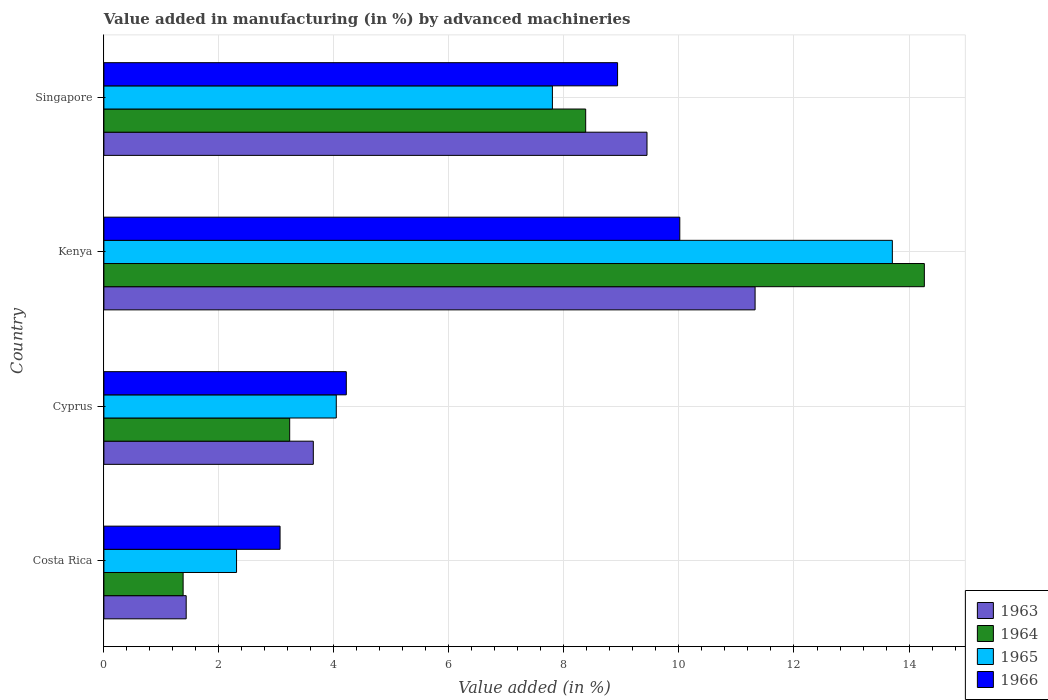How many different coloured bars are there?
Your answer should be very brief. 4. How many bars are there on the 1st tick from the top?
Your response must be concise. 4. How many bars are there on the 1st tick from the bottom?
Your answer should be very brief. 4. What is the label of the 3rd group of bars from the top?
Your response must be concise. Cyprus. What is the percentage of value added in manufacturing by advanced machineries in 1966 in Kenya?
Keep it short and to the point. 10.01. Across all countries, what is the maximum percentage of value added in manufacturing by advanced machineries in 1966?
Offer a very short reply. 10.01. Across all countries, what is the minimum percentage of value added in manufacturing by advanced machineries in 1965?
Ensure brevity in your answer.  2.31. In which country was the percentage of value added in manufacturing by advanced machineries in 1965 maximum?
Provide a short and direct response. Kenya. In which country was the percentage of value added in manufacturing by advanced machineries in 1963 minimum?
Provide a succinct answer. Costa Rica. What is the total percentage of value added in manufacturing by advanced machineries in 1966 in the graph?
Your response must be concise. 26.23. What is the difference between the percentage of value added in manufacturing by advanced machineries in 1963 in Costa Rica and that in Kenya?
Make the answer very short. -9.89. What is the difference between the percentage of value added in manufacturing by advanced machineries in 1964 in Costa Rica and the percentage of value added in manufacturing by advanced machineries in 1965 in Singapore?
Give a very brief answer. -6.42. What is the average percentage of value added in manufacturing by advanced machineries in 1964 per country?
Your answer should be compact. 6.81. What is the difference between the percentage of value added in manufacturing by advanced machineries in 1964 and percentage of value added in manufacturing by advanced machineries in 1965 in Singapore?
Your answer should be compact. 0.58. What is the ratio of the percentage of value added in manufacturing by advanced machineries in 1963 in Kenya to that in Singapore?
Your answer should be very brief. 1.2. Is the difference between the percentage of value added in manufacturing by advanced machineries in 1964 in Cyprus and Singapore greater than the difference between the percentage of value added in manufacturing by advanced machineries in 1965 in Cyprus and Singapore?
Make the answer very short. No. What is the difference between the highest and the second highest percentage of value added in manufacturing by advanced machineries in 1966?
Your response must be concise. 1.08. What is the difference between the highest and the lowest percentage of value added in manufacturing by advanced machineries in 1963?
Make the answer very short. 9.89. In how many countries, is the percentage of value added in manufacturing by advanced machineries in 1966 greater than the average percentage of value added in manufacturing by advanced machineries in 1966 taken over all countries?
Give a very brief answer. 2. What does the 4th bar from the bottom in Cyprus represents?
Your answer should be compact. 1966. How many bars are there?
Make the answer very short. 16. Are all the bars in the graph horizontal?
Provide a short and direct response. Yes. What is the difference between two consecutive major ticks on the X-axis?
Provide a short and direct response. 2. Does the graph contain any zero values?
Provide a short and direct response. No. Does the graph contain grids?
Your response must be concise. Yes. How many legend labels are there?
Give a very brief answer. 4. How are the legend labels stacked?
Make the answer very short. Vertical. What is the title of the graph?
Provide a short and direct response. Value added in manufacturing (in %) by advanced machineries. Does "1991" appear as one of the legend labels in the graph?
Keep it short and to the point. No. What is the label or title of the X-axis?
Your response must be concise. Value added (in %). What is the label or title of the Y-axis?
Your answer should be very brief. Country. What is the Value added (in %) in 1963 in Costa Rica?
Your response must be concise. 1.43. What is the Value added (in %) of 1964 in Costa Rica?
Your answer should be compact. 1.38. What is the Value added (in %) of 1965 in Costa Rica?
Make the answer very short. 2.31. What is the Value added (in %) in 1966 in Costa Rica?
Make the answer very short. 3.06. What is the Value added (in %) of 1963 in Cyprus?
Offer a terse response. 3.64. What is the Value added (in %) of 1964 in Cyprus?
Provide a succinct answer. 3.23. What is the Value added (in %) of 1965 in Cyprus?
Offer a terse response. 4.04. What is the Value added (in %) in 1966 in Cyprus?
Offer a very short reply. 4.22. What is the Value added (in %) of 1963 in Kenya?
Give a very brief answer. 11.32. What is the Value added (in %) in 1964 in Kenya?
Your response must be concise. 14.27. What is the Value added (in %) of 1965 in Kenya?
Give a very brief answer. 13.71. What is the Value added (in %) in 1966 in Kenya?
Offer a terse response. 10.01. What is the Value added (in %) of 1963 in Singapore?
Your response must be concise. 9.44. What is the Value added (in %) in 1964 in Singapore?
Ensure brevity in your answer.  8.38. What is the Value added (in %) in 1965 in Singapore?
Offer a very short reply. 7.8. What is the Value added (in %) of 1966 in Singapore?
Offer a very short reply. 8.93. Across all countries, what is the maximum Value added (in %) in 1963?
Give a very brief answer. 11.32. Across all countries, what is the maximum Value added (in %) of 1964?
Provide a succinct answer. 14.27. Across all countries, what is the maximum Value added (in %) of 1965?
Offer a very short reply. 13.71. Across all countries, what is the maximum Value added (in %) of 1966?
Your response must be concise. 10.01. Across all countries, what is the minimum Value added (in %) of 1963?
Your answer should be compact. 1.43. Across all countries, what is the minimum Value added (in %) in 1964?
Your answer should be very brief. 1.38. Across all countries, what is the minimum Value added (in %) of 1965?
Keep it short and to the point. 2.31. Across all countries, what is the minimum Value added (in %) in 1966?
Provide a succinct answer. 3.06. What is the total Value added (in %) in 1963 in the graph?
Keep it short and to the point. 25.84. What is the total Value added (in %) in 1964 in the graph?
Make the answer very short. 27.25. What is the total Value added (in %) of 1965 in the graph?
Make the answer very short. 27.86. What is the total Value added (in %) in 1966 in the graph?
Keep it short and to the point. 26.23. What is the difference between the Value added (in %) of 1963 in Costa Rica and that in Cyprus?
Provide a succinct answer. -2.21. What is the difference between the Value added (in %) in 1964 in Costa Rica and that in Cyprus?
Your answer should be compact. -1.85. What is the difference between the Value added (in %) in 1965 in Costa Rica and that in Cyprus?
Offer a very short reply. -1.73. What is the difference between the Value added (in %) in 1966 in Costa Rica and that in Cyprus?
Your response must be concise. -1.15. What is the difference between the Value added (in %) in 1963 in Costa Rica and that in Kenya?
Offer a terse response. -9.89. What is the difference between the Value added (in %) of 1964 in Costa Rica and that in Kenya?
Your answer should be compact. -12.89. What is the difference between the Value added (in %) of 1965 in Costa Rica and that in Kenya?
Your answer should be compact. -11.4. What is the difference between the Value added (in %) of 1966 in Costa Rica and that in Kenya?
Keep it short and to the point. -6.95. What is the difference between the Value added (in %) of 1963 in Costa Rica and that in Singapore?
Offer a terse response. -8.01. What is the difference between the Value added (in %) in 1964 in Costa Rica and that in Singapore?
Offer a very short reply. -7. What is the difference between the Value added (in %) of 1965 in Costa Rica and that in Singapore?
Provide a succinct answer. -5.49. What is the difference between the Value added (in %) of 1966 in Costa Rica and that in Singapore?
Make the answer very short. -5.87. What is the difference between the Value added (in %) of 1963 in Cyprus and that in Kenya?
Offer a very short reply. -7.68. What is the difference between the Value added (in %) of 1964 in Cyprus and that in Kenya?
Your response must be concise. -11.04. What is the difference between the Value added (in %) in 1965 in Cyprus and that in Kenya?
Your answer should be compact. -9.67. What is the difference between the Value added (in %) in 1966 in Cyprus and that in Kenya?
Your response must be concise. -5.8. What is the difference between the Value added (in %) of 1963 in Cyprus and that in Singapore?
Your answer should be very brief. -5.8. What is the difference between the Value added (in %) in 1964 in Cyprus and that in Singapore?
Keep it short and to the point. -5.15. What is the difference between the Value added (in %) of 1965 in Cyprus and that in Singapore?
Offer a very short reply. -3.76. What is the difference between the Value added (in %) of 1966 in Cyprus and that in Singapore?
Offer a terse response. -4.72. What is the difference between the Value added (in %) of 1963 in Kenya and that in Singapore?
Offer a terse response. 1.88. What is the difference between the Value added (in %) in 1964 in Kenya and that in Singapore?
Provide a short and direct response. 5.89. What is the difference between the Value added (in %) in 1965 in Kenya and that in Singapore?
Ensure brevity in your answer.  5.91. What is the difference between the Value added (in %) of 1966 in Kenya and that in Singapore?
Keep it short and to the point. 1.08. What is the difference between the Value added (in %) in 1963 in Costa Rica and the Value added (in %) in 1964 in Cyprus?
Ensure brevity in your answer.  -1.8. What is the difference between the Value added (in %) of 1963 in Costa Rica and the Value added (in %) of 1965 in Cyprus?
Your response must be concise. -2.61. What is the difference between the Value added (in %) of 1963 in Costa Rica and the Value added (in %) of 1966 in Cyprus?
Your response must be concise. -2.78. What is the difference between the Value added (in %) in 1964 in Costa Rica and the Value added (in %) in 1965 in Cyprus?
Your response must be concise. -2.66. What is the difference between the Value added (in %) in 1964 in Costa Rica and the Value added (in %) in 1966 in Cyprus?
Offer a terse response. -2.84. What is the difference between the Value added (in %) of 1965 in Costa Rica and the Value added (in %) of 1966 in Cyprus?
Provide a succinct answer. -1.91. What is the difference between the Value added (in %) in 1963 in Costa Rica and the Value added (in %) in 1964 in Kenya?
Offer a very short reply. -12.84. What is the difference between the Value added (in %) in 1963 in Costa Rica and the Value added (in %) in 1965 in Kenya?
Offer a terse response. -12.28. What is the difference between the Value added (in %) in 1963 in Costa Rica and the Value added (in %) in 1966 in Kenya?
Make the answer very short. -8.58. What is the difference between the Value added (in %) in 1964 in Costa Rica and the Value added (in %) in 1965 in Kenya?
Keep it short and to the point. -12.33. What is the difference between the Value added (in %) in 1964 in Costa Rica and the Value added (in %) in 1966 in Kenya?
Make the answer very short. -8.64. What is the difference between the Value added (in %) in 1965 in Costa Rica and the Value added (in %) in 1966 in Kenya?
Keep it short and to the point. -7.71. What is the difference between the Value added (in %) in 1963 in Costa Rica and the Value added (in %) in 1964 in Singapore?
Your answer should be very brief. -6.95. What is the difference between the Value added (in %) of 1963 in Costa Rica and the Value added (in %) of 1965 in Singapore?
Provide a short and direct response. -6.37. What is the difference between the Value added (in %) of 1963 in Costa Rica and the Value added (in %) of 1966 in Singapore?
Provide a short and direct response. -7.5. What is the difference between the Value added (in %) in 1964 in Costa Rica and the Value added (in %) in 1965 in Singapore?
Ensure brevity in your answer.  -6.42. What is the difference between the Value added (in %) of 1964 in Costa Rica and the Value added (in %) of 1966 in Singapore?
Provide a succinct answer. -7.55. What is the difference between the Value added (in %) in 1965 in Costa Rica and the Value added (in %) in 1966 in Singapore?
Offer a terse response. -6.63. What is the difference between the Value added (in %) of 1963 in Cyprus and the Value added (in %) of 1964 in Kenya?
Keep it short and to the point. -10.63. What is the difference between the Value added (in %) of 1963 in Cyprus and the Value added (in %) of 1965 in Kenya?
Offer a very short reply. -10.07. What is the difference between the Value added (in %) in 1963 in Cyprus and the Value added (in %) in 1966 in Kenya?
Ensure brevity in your answer.  -6.37. What is the difference between the Value added (in %) in 1964 in Cyprus and the Value added (in %) in 1965 in Kenya?
Your answer should be compact. -10.48. What is the difference between the Value added (in %) of 1964 in Cyprus and the Value added (in %) of 1966 in Kenya?
Provide a succinct answer. -6.78. What is the difference between the Value added (in %) of 1965 in Cyprus and the Value added (in %) of 1966 in Kenya?
Give a very brief answer. -5.97. What is the difference between the Value added (in %) in 1963 in Cyprus and the Value added (in %) in 1964 in Singapore?
Keep it short and to the point. -4.74. What is the difference between the Value added (in %) of 1963 in Cyprus and the Value added (in %) of 1965 in Singapore?
Ensure brevity in your answer.  -4.16. What is the difference between the Value added (in %) of 1963 in Cyprus and the Value added (in %) of 1966 in Singapore?
Ensure brevity in your answer.  -5.29. What is the difference between the Value added (in %) in 1964 in Cyprus and the Value added (in %) in 1965 in Singapore?
Keep it short and to the point. -4.57. What is the difference between the Value added (in %) in 1964 in Cyprus and the Value added (in %) in 1966 in Singapore?
Your response must be concise. -5.7. What is the difference between the Value added (in %) in 1965 in Cyprus and the Value added (in %) in 1966 in Singapore?
Keep it short and to the point. -4.89. What is the difference between the Value added (in %) in 1963 in Kenya and the Value added (in %) in 1964 in Singapore?
Offer a terse response. 2.95. What is the difference between the Value added (in %) of 1963 in Kenya and the Value added (in %) of 1965 in Singapore?
Make the answer very short. 3.52. What is the difference between the Value added (in %) in 1963 in Kenya and the Value added (in %) in 1966 in Singapore?
Offer a very short reply. 2.39. What is the difference between the Value added (in %) in 1964 in Kenya and the Value added (in %) in 1965 in Singapore?
Provide a short and direct response. 6.47. What is the difference between the Value added (in %) of 1964 in Kenya and the Value added (in %) of 1966 in Singapore?
Your response must be concise. 5.33. What is the difference between the Value added (in %) of 1965 in Kenya and the Value added (in %) of 1966 in Singapore?
Provide a short and direct response. 4.78. What is the average Value added (in %) in 1963 per country?
Keep it short and to the point. 6.46. What is the average Value added (in %) of 1964 per country?
Your answer should be very brief. 6.81. What is the average Value added (in %) of 1965 per country?
Keep it short and to the point. 6.96. What is the average Value added (in %) of 1966 per country?
Your answer should be compact. 6.56. What is the difference between the Value added (in %) in 1963 and Value added (in %) in 1964 in Costa Rica?
Your answer should be compact. 0.05. What is the difference between the Value added (in %) of 1963 and Value added (in %) of 1965 in Costa Rica?
Offer a very short reply. -0.88. What is the difference between the Value added (in %) in 1963 and Value added (in %) in 1966 in Costa Rica?
Offer a very short reply. -1.63. What is the difference between the Value added (in %) of 1964 and Value added (in %) of 1965 in Costa Rica?
Your response must be concise. -0.93. What is the difference between the Value added (in %) of 1964 and Value added (in %) of 1966 in Costa Rica?
Your response must be concise. -1.69. What is the difference between the Value added (in %) of 1965 and Value added (in %) of 1966 in Costa Rica?
Make the answer very short. -0.76. What is the difference between the Value added (in %) of 1963 and Value added (in %) of 1964 in Cyprus?
Your response must be concise. 0.41. What is the difference between the Value added (in %) in 1963 and Value added (in %) in 1965 in Cyprus?
Offer a terse response. -0.4. What is the difference between the Value added (in %) in 1963 and Value added (in %) in 1966 in Cyprus?
Keep it short and to the point. -0.57. What is the difference between the Value added (in %) in 1964 and Value added (in %) in 1965 in Cyprus?
Offer a terse response. -0.81. What is the difference between the Value added (in %) in 1964 and Value added (in %) in 1966 in Cyprus?
Your response must be concise. -0.98. What is the difference between the Value added (in %) of 1965 and Value added (in %) of 1966 in Cyprus?
Offer a very short reply. -0.17. What is the difference between the Value added (in %) in 1963 and Value added (in %) in 1964 in Kenya?
Provide a succinct answer. -2.94. What is the difference between the Value added (in %) in 1963 and Value added (in %) in 1965 in Kenya?
Provide a succinct answer. -2.39. What is the difference between the Value added (in %) in 1963 and Value added (in %) in 1966 in Kenya?
Offer a very short reply. 1.31. What is the difference between the Value added (in %) in 1964 and Value added (in %) in 1965 in Kenya?
Make the answer very short. 0.56. What is the difference between the Value added (in %) of 1964 and Value added (in %) of 1966 in Kenya?
Keep it short and to the point. 4.25. What is the difference between the Value added (in %) in 1965 and Value added (in %) in 1966 in Kenya?
Ensure brevity in your answer.  3.7. What is the difference between the Value added (in %) of 1963 and Value added (in %) of 1964 in Singapore?
Your answer should be very brief. 1.07. What is the difference between the Value added (in %) in 1963 and Value added (in %) in 1965 in Singapore?
Your answer should be very brief. 1.64. What is the difference between the Value added (in %) of 1963 and Value added (in %) of 1966 in Singapore?
Give a very brief answer. 0.51. What is the difference between the Value added (in %) of 1964 and Value added (in %) of 1965 in Singapore?
Ensure brevity in your answer.  0.58. What is the difference between the Value added (in %) of 1964 and Value added (in %) of 1966 in Singapore?
Provide a short and direct response. -0.55. What is the difference between the Value added (in %) of 1965 and Value added (in %) of 1966 in Singapore?
Offer a terse response. -1.13. What is the ratio of the Value added (in %) in 1963 in Costa Rica to that in Cyprus?
Keep it short and to the point. 0.39. What is the ratio of the Value added (in %) in 1964 in Costa Rica to that in Cyprus?
Your answer should be compact. 0.43. What is the ratio of the Value added (in %) of 1965 in Costa Rica to that in Cyprus?
Provide a short and direct response. 0.57. What is the ratio of the Value added (in %) of 1966 in Costa Rica to that in Cyprus?
Provide a short and direct response. 0.73. What is the ratio of the Value added (in %) in 1963 in Costa Rica to that in Kenya?
Your answer should be very brief. 0.13. What is the ratio of the Value added (in %) in 1964 in Costa Rica to that in Kenya?
Make the answer very short. 0.1. What is the ratio of the Value added (in %) in 1965 in Costa Rica to that in Kenya?
Offer a terse response. 0.17. What is the ratio of the Value added (in %) of 1966 in Costa Rica to that in Kenya?
Offer a terse response. 0.31. What is the ratio of the Value added (in %) in 1963 in Costa Rica to that in Singapore?
Offer a terse response. 0.15. What is the ratio of the Value added (in %) in 1964 in Costa Rica to that in Singapore?
Your response must be concise. 0.16. What is the ratio of the Value added (in %) of 1965 in Costa Rica to that in Singapore?
Offer a very short reply. 0.3. What is the ratio of the Value added (in %) in 1966 in Costa Rica to that in Singapore?
Make the answer very short. 0.34. What is the ratio of the Value added (in %) in 1963 in Cyprus to that in Kenya?
Your answer should be very brief. 0.32. What is the ratio of the Value added (in %) in 1964 in Cyprus to that in Kenya?
Your answer should be compact. 0.23. What is the ratio of the Value added (in %) of 1965 in Cyprus to that in Kenya?
Make the answer very short. 0.29. What is the ratio of the Value added (in %) of 1966 in Cyprus to that in Kenya?
Make the answer very short. 0.42. What is the ratio of the Value added (in %) in 1963 in Cyprus to that in Singapore?
Ensure brevity in your answer.  0.39. What is the ratio of the Value added (in %) of 1964 in Cyprus to that in Singapore?
Provide a short and direct response. 0.39. What is the ratio of the Value added (in %) in 1965 in Cyprus to that in Singapore?
Ensure brevity in your answer.  0.52. What is the ratio of the Value added (in %) in 1966 in Cyprus to that in Singapore?
Your answer should be compact. 0.47. What is the ratio of the Value added (in %) of 1963 in Kenya to that in Singapore?
Make the answer very short. 1.2. What is the ratio of the Value added (in %) of 1964 in Kenya to that in Singapore?
Your answer should be very brief. 1.7. What is the ratio of the Value added (in %) in 1965 in Kenya to that in Singapore?
Offer a terse response. 1.76. What is the ratio of the Value added (in %) in 1966 in Kenya to that in Singapore?
Ensure brevity in your answer.  1.12. What is the difference between the highest and the second highest Value added (in %) in 1963?
Give a very brief answer. 1.88. What is the difference between the highest and the second highest Value added (in %) of 1964?
Offer a very short reply. 5.89. What is the difference between the highest and the second highest Value added (in %) in 1965?
Provide a succinct answer. 5.91. What is the difference between the highest and the second highest Value added (in %) in 1966?
Your answer should be very brief. 1.08. What is the difference between the highest and the lowest Value added (in %) of 1963?
Provide a succinct answer. 9.89. What is the difference between the highest and the lowest Value added (in %) in 1964?
Your answer should be compact. 12.89. What is the difference between the highest and the lowest Value added (in %) of 1965?
Offer a terse response. 11.4. What is the difference between the highest and the lowest Value added (in %) of 1966?
Ensure brevity in your answer.  6.95. 